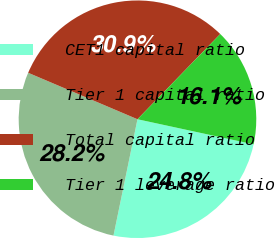<chart> <loc_0><loc_0><loc_500><loc_500><pie_chart><fcel>CET1 capital ratio<fcel>Tier 1 capital ratio<fcel>Total capital ratio<fcel>Tier 1 leverage ratio<nl><fcel>24.85%<fcel>28.16%<fcel>30.87%<fcel>16.12%<nl></chart> 